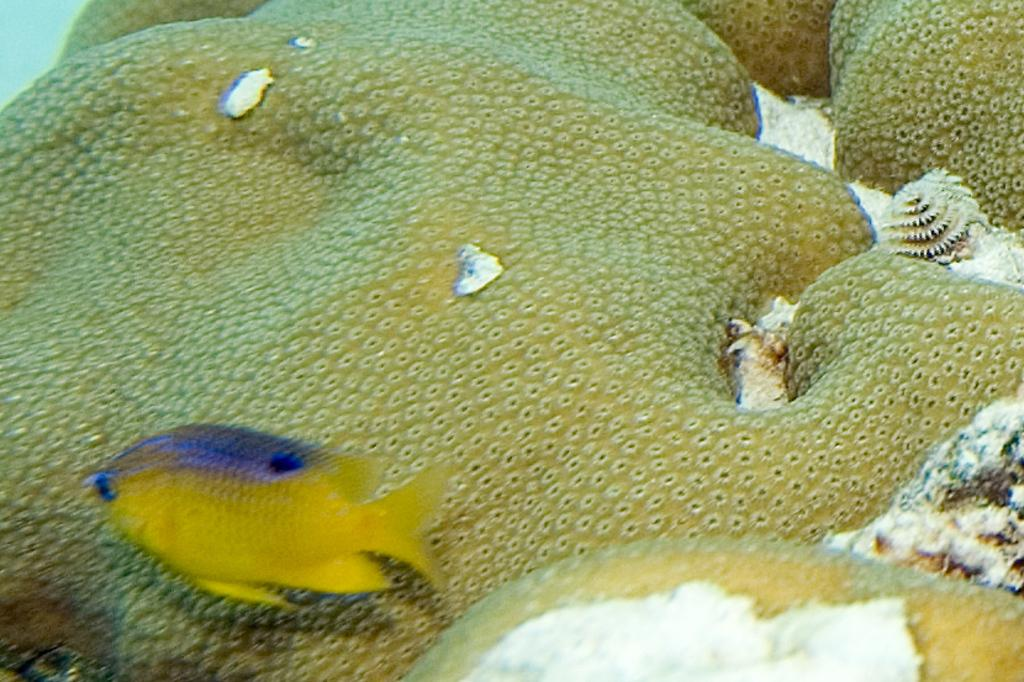What is the main subject of the image? There is a fish in the image. What is the fish doing in the image? The fish is swimming in the water. What color is the fish? The fish is yellow in color. How far away is the faucet from the fish in the image? There is no faucet present in the image. What type of war is depicted in the image? There is no war depicted in the image; it features a yellow fish swimming in the water. 